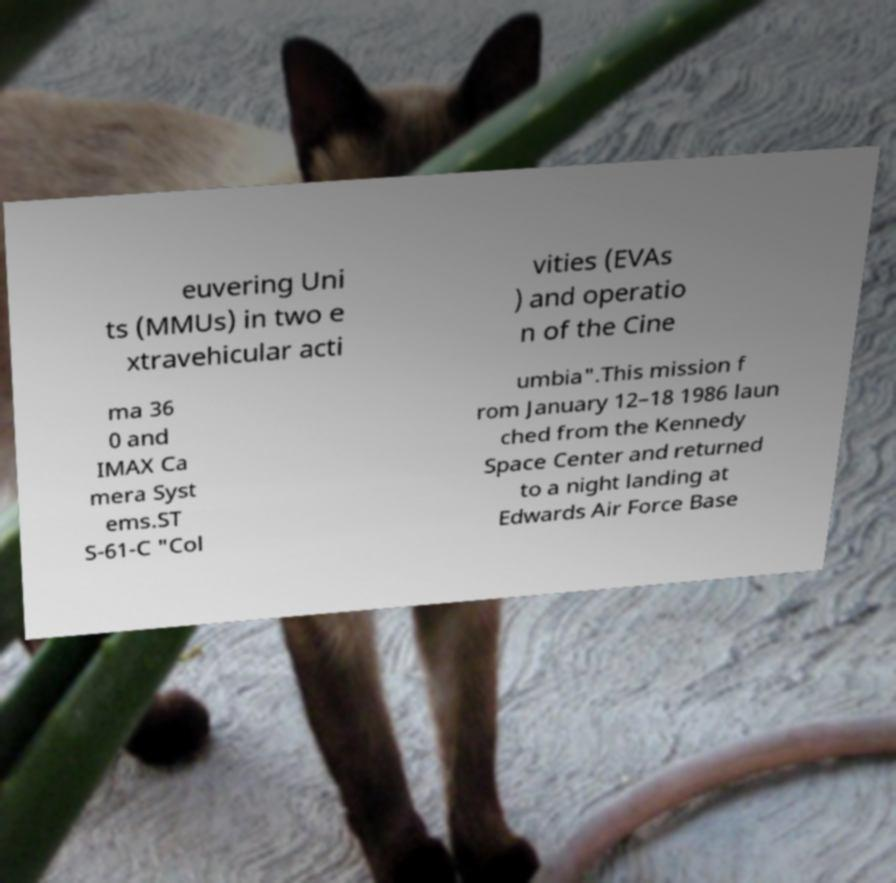Can you read and provide the text displayed in the image?This photo seems to have some interesting text. Can you extract and type it out for me? euvering Uni ts (MMUs) in two e xtravehicular acti vities (EVAs ) and operatio n of the Cine ma 36 0 and IMAX Ca mera Syst ems.ST S-61-C "Col umbia".This mission f rom January 12–18 1986 laun ched from the Kennedy Space Center and returned to a night landing at Edwards Air Force Base 